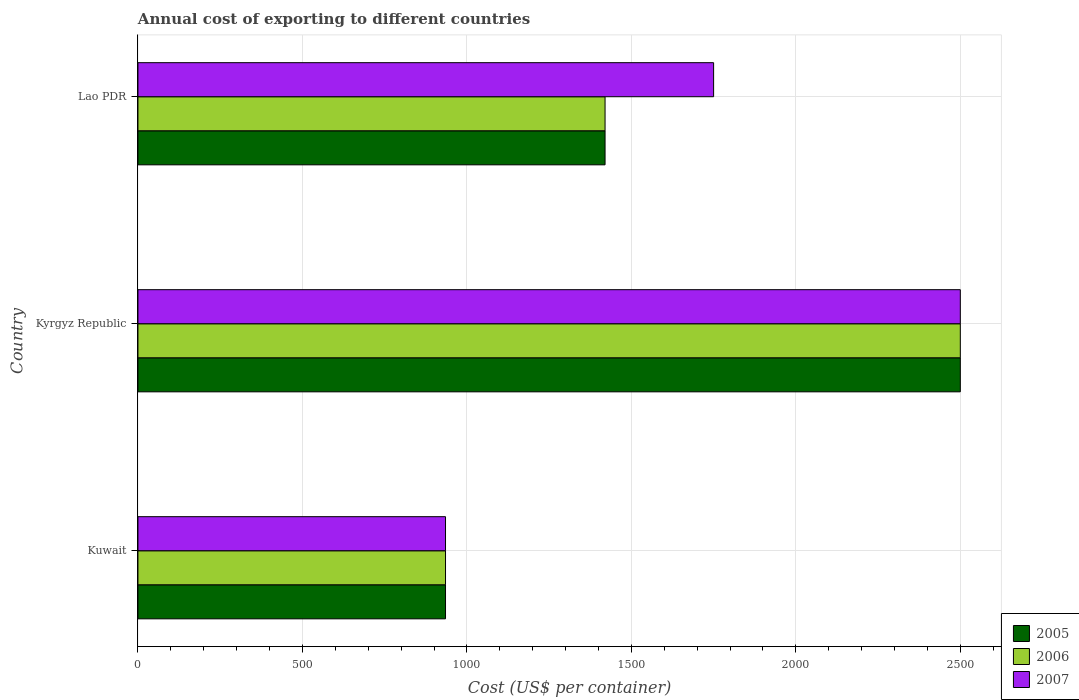How many different coloured bars are there?
Your answer should be compact. 3. How many groups of bars are there?
Offer a very short reply. 3. How many bars are there on the 2nd tick from the bottom?
Your answer should be compact. 3. What is the label of the 3rd group of bars from the top?
Your answer should be compact. Kuwait. In how many cases, is the number of bars for a given country not equal to the number of legend labels?
Your answer should be compact. 0. What is the total annual cost of exporting in 2005 in Kuwait?
Give a very brief answer. 935. Across all countries, what is the maximum total annual cost of exporting in 2007?
Make the answer very short. 2500. Across all countries, what is the minimum total annual cost of exporting in 2005?
Offer a very short reply. 935. In which country was the total annual cost of exporting in 2005 maximum?
Make the answer very short. Kyrgyz Republic. In which country was the total annual cost of exporting in 2005 minimum?
Keep it short and to the point. Kuwait. What is the total total annual cost of exporting in 2006 in the graph?
Offer a terse response. 4855. What is the difference between the total annual cost of exporting in 2006 in Kuwait and that in Kyrgyz Republic?
Offer a terse response. -1565. What is the difference between the total annual cost of exporting in 2006 in Kuwait and the total annual cost of exporting in 2007 in Kyrgyz Republic?
Provide a succinct answer. -1565. What is the average total annual cost of exporting in 2007 per country?
Your answer should be very brief. 1728.33. What is the difference between the total annual cost of exporting in 2006 and total annual cost of exporting in 2007 in Kuwait?
Offer a terse response. 0. What is the ratio of the total annual cost of exporting in 2007 in Kyrgyz Republic to that in Lao PDR?
Your answer should be compact. 1.43. Is the total annual cost of exporting in 2007 in Kuwait less than that in Kyrgyz Republic?
Make the answer very short. Yes. What is the difference between the highest and the second highest total annual cost of exporting in 2007?
Offer a very short reply. 750. What is the difference between the highest and the lowest total annual cost of exporting in 2007?
Provide a succinct answer. 1565. In how many countries, is the total annual cost of exporting in 2005 greater than the average total annual cost of exporting in 2005 taken over all countries?
Make the answer very short. 1. Are all the bars in the graph horizontal?
Give a very brief answer. Yes. How many countries are there in the graph?
Offer a terse response. 3. What is the difference between two consecutive major ticks on the X-axis?
Your answer should be very brief. 500. Are the values on the major ticks of X-axis written in scientific E-notation?
Offer a very short reply. No. Does the graph contain any zero values?
Give a very brief answer. No. How many legend labels are there?
Provide a short and direct response. 3. How are the legend labels stacked?
Offer a terse response. Vertical. What is the title of the graph?
Ensure brevity in your answer.  Annual cost of exporting to different countries. Does "1998" appear as one of the legend labels in the graph?
Your answer should be very brief. No. What is the label or title of the X-axis?
Provide a succinct answer. Cost (US$ per container). What is the Cost (US$ per container) of 2005 in Kuwait?
Give a very brief answer. 935. What is the Cost (US$ per container) in 2006 in Kuwait?
Provide a short and direct response. 935. What is the Cost (US$ per container) of 2007 in Kuwait?
Keep it short and to the point. 935. What is the Cost (US$ per container) in 2005 in Kyrgyz Republic?
Provide a short and direct response. 2500. What is the Cost (US$ per container) in 2006 in Kyrgyz Republic?
Ensure brevity in your answer.  2500. What is the Cost (US$ per container) of 2007 in Kyrgyz Republic?
Provide a succinct answer. 2500. What is the Cost (US$ per container) in 2005 in Lao PDR?
Offer a terse response. 1420. What is the Cost (US$ per container) of 2006 in Lao PDR?
Give a very brief answer. 1420. What is the Cost (US$ per container) of 2007 in Lao PDR?
Provide a short and direct response. 1750. Across all countries, what is the maximum Cost (US$ per container) in 2005?
Provide a succinct answer. 2500. Across all countries, what is the maximum Cost (US$ per container) in 2006?
Offer a terse response. 2500. Across all countries, what is the maximum Cost (US$ per container) of 2007?
Provide a short and direct response. 2500. Across all countries, what is the minimum Cost (US$ per container) in 2005?
Keep it short and to the point. 935. Across all countries, what is the minimum Cost (US$ per container) of 2006?
Your answer should be very brief. 935. Across all countries, what is the minimum Cost (US$ per container) of 2007?
Ensure brevity in your answer.  935. What is the total Cost (US$ per container) in 2005 in the graph?
Make the answer very short. 4855. What is the total Cost (US$ per container) in 2006 in the graph?
Offer a terse response. 4855. What is the total Cost (US$ per container) of 2007 in the graph?
Keep it short and to the point. 5185. What is the difference between the Cost (US$ per container) in 2005 in Kuwait and that in Kyrgyz Republic?
Your answer should be very brief. -1565. What is the difference between the Cost (US$ per container) in 2006 in Kuwait and that in Kyrgyz Republic?
Provide a short and direct response. -1565. What is the difference between the Cost (US$ per container) of 2007 in Kuwait and that in Kyrgyz Republic?
Your answer should be very brief. -1565. What is the difference between the Cost (US$ per container) in 2005 in Kuwait and that in Lao PDR?
Offer a terse response. -485. What is the difference between the Cost (US$ per container) of 2006 in Kuwait and that in Lao PDR?
Provide a short and direct response. -485. What is the difference between the Cost (US$ per container) of 2007 in Kuwait and that in Lao PDR?
Make the answer very short. -815. What is the difference between the Cost (US$ per container) in 2005 in Kyrgyz Republic and that in Lao PDR?
Offer a terse response. 1080. What is the difference between the Cost (US$ per container) of 2006 in Kyrgyz Republic and that in Lao PDR?
Offer a very short reply. 1080. What is the difference between the Cost (US$ per container) of 2007 in Kyrgyz Republic and that in Lao PDR?
Ensure brevity in your answer.  750. What is the difference between the Cost (US$ per container) of 2005 in Kuwait and the Cost (US$ per container) of 2006 in Kyrgyz Republic?
Make the answer very short. -1565. What is the difference between the Cost (US$ per container) of 2005 in Kuwait and the Cost (US$ per container) of 2007 in Kyrgyz Republic?
Provide a succinct answer. -1565. What is the difference between the Cost (US$ per container) in 2006 in Kuwait and the Cost (US$ per container) in 2007 in Kyrgyz Republic?
Offer a very short reply. -1565. What is the difference between the Cost (US$ per container) of 2005 in Kuwait and the Cost (US$ per container) of 2006 in Lao PDR?
Offer a terse response. -485. What is the difference between the Cost (US$ per container) in 2005 in Kuwait and the Cost (US$ per container) in 2007 in Lao PDR?
Make the answer very short. -815. What is the difference between the Cost (US$ per container) of 2006 in Kuwait and the Cost (US$ per container) of 2007 in Lao PDR?
Provide a succinct answer. -815. What is the difference between the Cost (US$ per container) in 2005 in Kyrgyz Republic and the Cost (US$ per container) in 2006 in Lao PDR?
Keep it short and to the point. 1080. What is the difference between the Cost (US$ per container) of 2005 in Kyrgyz Republic and the Cost (US$ per container) of 2007 in Lao PDR?
Provide a short and direct response. 750. What is the difference between the Cost (US$ per container) in 2006 in Kyrgyz Republic and the Cost (US$ per container) in 2007 in Lao PDR?
Provide a short and direct response. 750. What is the average Cost (US$ per container) of 2005 per country?
Give a very brief answer. 1618.33. What is the average Cost (US$ per container) of 2006 per country?
Your response must be concise. 1618.33. What is the average Cost (US$ per container) in 2007 per country?
Provide a short and direct response. 1728.33. What is the difference between the Cost (US$ per container) of 2005 and Cost (US$ per container) of 2006 in Kyrgyz Republic?
Offer a very short reply. 0. What is the difference between the Cost (US$ per container) in 2005 and Cost (US$ per container) in 2007 in Kyrgyz Republic?
Provide a short and direct response. 0. What is the difference between the Cost (US$ per container) of 2005 and Cost (US$ per container) of 2006 in Lao PDR?
Offer a terse response. 0. What is the difference between the Cost (US$ per container) of 2005 and Cost (US$ per container) of 2007 in Lao PDR?
Your response must be concise. -330. What is the difference between the Cost (US$ per container) in 2006 and Cost (US$ per container) in 2007 in Lao PDR?
Your answer should be very brief. -330. What is the ratio of the Cost (US$ per container) in 2005 in Kuwait to that in Kyrgyz Republic?
Offer a very short reply. 0.37. What is the ratio of the Cost (US$ per container) in 2006 in Kuwait to that in Kyrgyz Republic?
Provide a short and direct response. 0.37. What is the ratio of the Cost (US$ per container) in 2007 in Kuwait to that in Kyrgyz Republic?
Keep it short and to the point. 0.37. What is the ratio of the Cost (US$ per container) of 2005 in Kuwait to that in Lao PDR?
Give a very brief answer. 0.66. What is the ratio of the Cost (US$ per container) of 2006 in Kuwait to that in Lao PDR?
Offer a terse response. 0.66. What is the ratio of the Cost (US$ per container) in 2007 in Kuwait to that in Lao PDR?
Your answer should be compact. 0.53. What is the ratio of the Cost (US$ per container) in 2005 in Kyrgyz Republic to that in Lao PDR?
Offer a very short reply. 1.76. What is the ratio of the Cost (US$ per container) in 2006 in Kyrgyz Republic to that in Lao PDR?
Your answer should be compact. 1.76. What is the ratio of the Cost (US$ per container) in 2007 in Kyrgyz Republic to that in Lao PDR?
Keep it short and to the point. 1.43. What is the difference between the highest and the second highest Cost (US$ per container) in 2005?
Your answer should be very brief. 1080. What is the difference between the highest and the second highest Cost (US$ per container) of 2006?
Your response must be concise. 1080. What is the difference between the highest and the second highest Cost (US$ per container) of 2007?
Your response must be concise. 750. What is the difference between the highest and the lowest Cost (US$ per container) of 2005?
Make the answer very short. 1565. What is the difference between the highest and the lowest Cost (US$ per container) in 2006?
Make the answer very short. 1565. What is the difference between the highest and the lowest Cost (US$ per container) of 2007?
Give a very brief answer. 1565. 